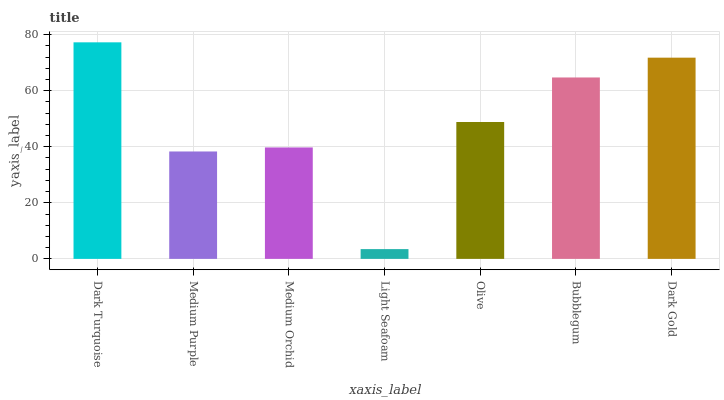Is Light Seafoam the minimum?
Answer yes or no. Yes. Is Dark Turquoise the maximum?
Answer yes or no. Yes. Is Medium Purple the minimum?
Answer yes or no. No. Is Medium Purple the maximum?
Answer yes or no. No. Is Dark Turquoise greater than Medium Purple?
Answer yes or no. Yes. Is Medium Purple less than Dark Turquoise?
Answer yes or no. Yes. Is Medium Purple greater than Dark Turquoise?
Answer yes or no. No. Is Dark Turquoise less than Medium Purple?
Answer yes or no. No. Is Olive the high median?
Answer yes or no. Yes. Is Olive the low median?
Answer yes or no. Yes. Is Bubblegum the high median?
Answer yes or no. No. Is Medium Purple the low median?
Answer yes or no. No. 